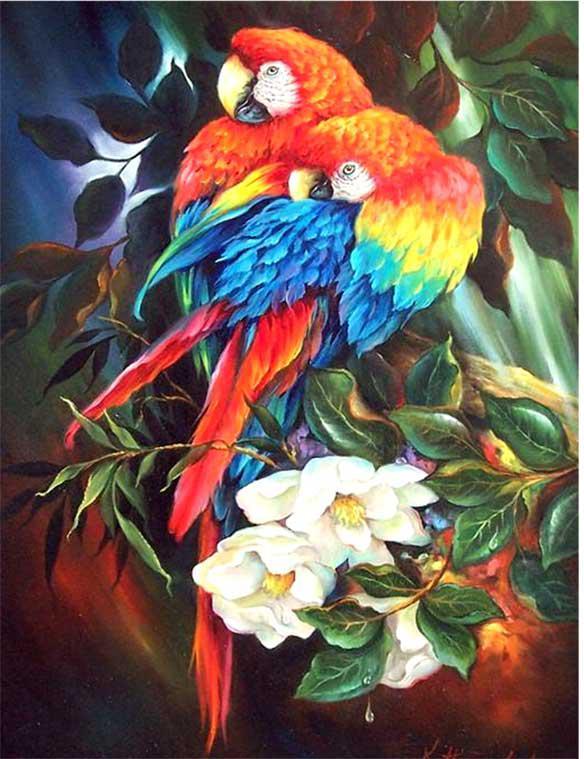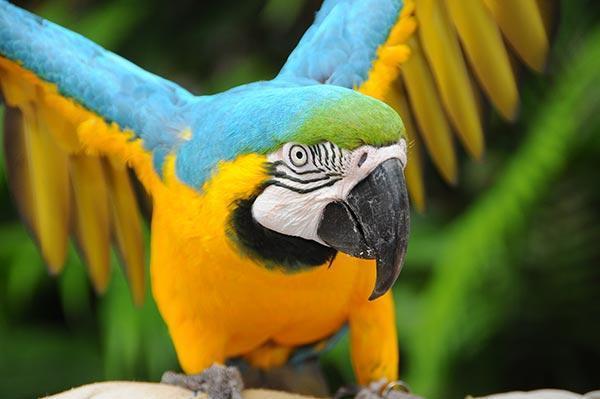The first image is the image on the left, the second image is the image on the right. Assess this claim about the two images: "There are two real birds with white faces in black beaks sitting next to each other on a branch.". Correct or not? Answer yes or no. No. 